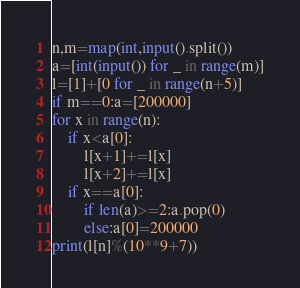<code> <loc_0><loc_0><loc_500><loc_500><_Python_>n,m=map(int,input().split())
a=[int(input()) for _ in range(m)]
l=[1]+[0 for _ in range(n+5)]
if m==0:a=[200000]
for x in range(n):
    if x<a[0]:
        l[x+1]+=l[x]
        l[x+2]+=l[x]
    if x==a[0]:
        if len(a)>=2:a.pop(0)
        else:a[0]=200000
print(l[n]%(10**9+7))</code> 